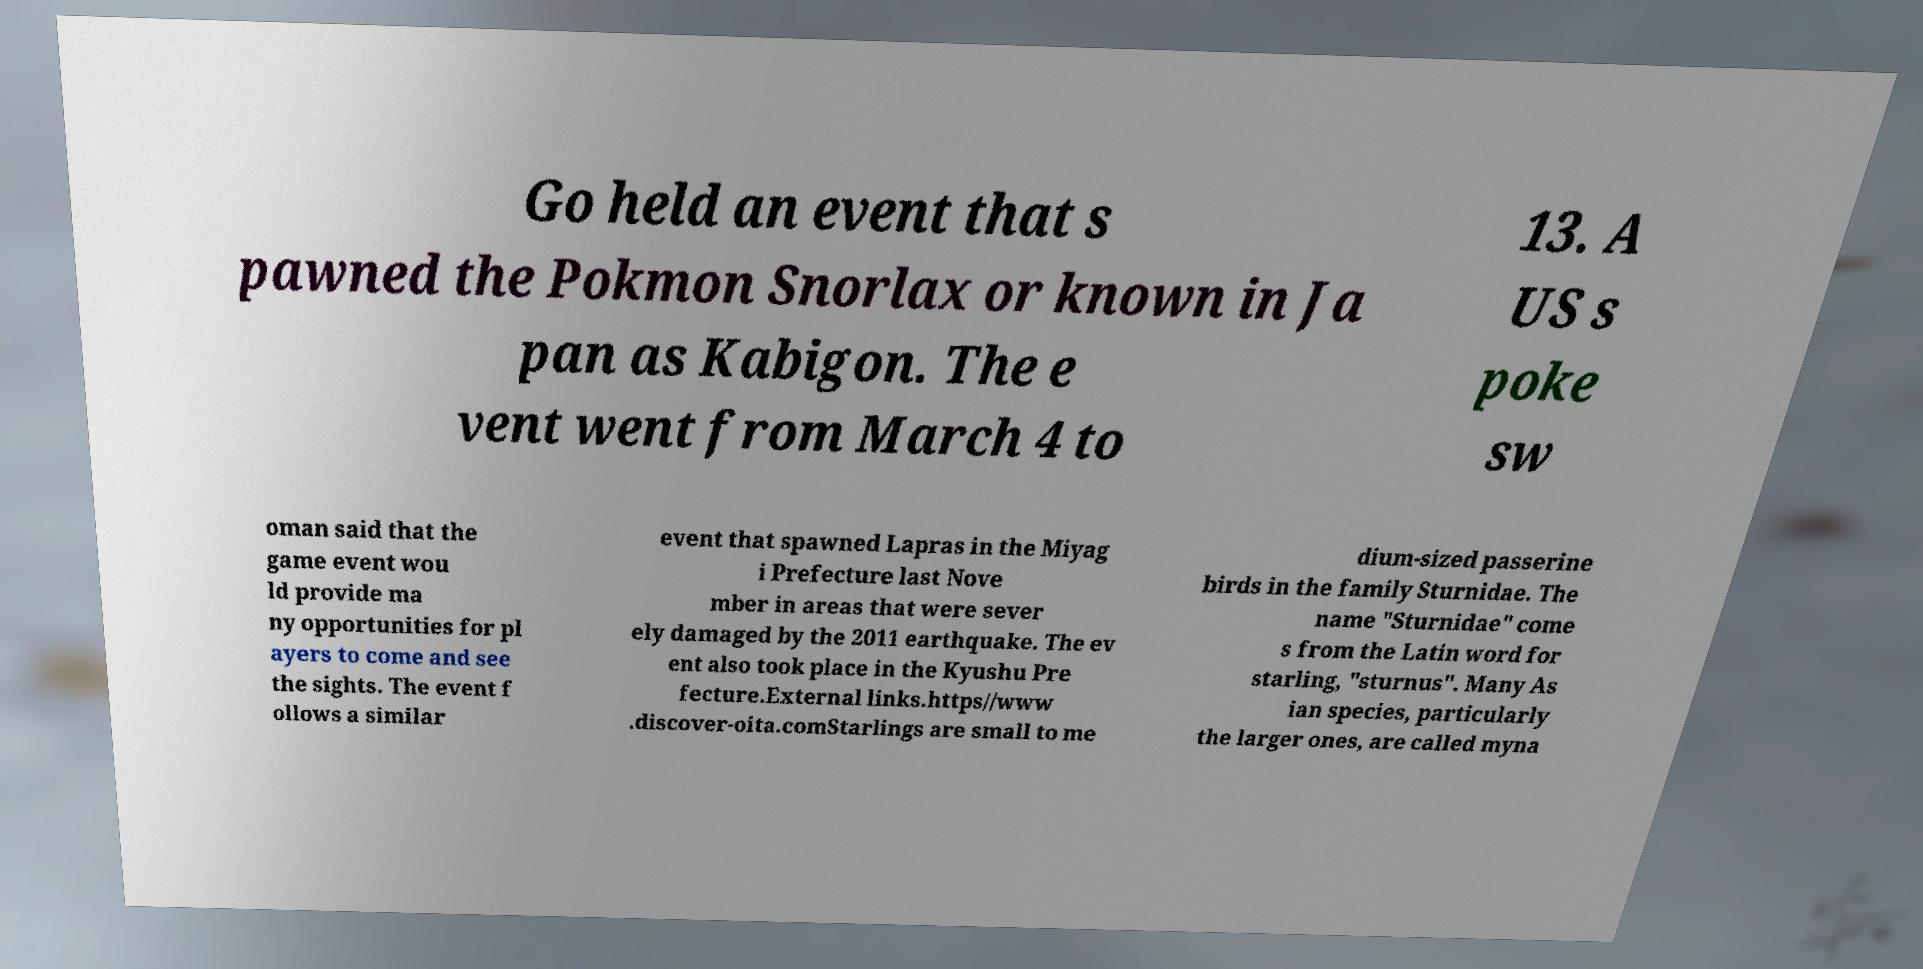There's text embedded in this image that I need extracted. Can you transcribe it verbatim? Go held an event that s pawned the Pokmon Snorlax or known in Ja pan as Kabigon. The e vent went from March 4 to 13. A US s poke sw oman said that the game event wou ld provide ma ny opportunities for pl ayers to come and see the sights. The event f ollows a similar event that spawned Lapras in the Miyag i Prefecture last Nove mber in areas that were sever ely damaged by the 2011 earthquake. The ev ent also took place in the Kyushu Pre fecture.External links.https//www .discover-oita.comStarlings are small to me dium-sized passerine birds in the family Sturnidae. The name "Sturnidae" come s from the Latin word for starling, "sturnus". Many As ian species, particularly the larger ones, are called myna 